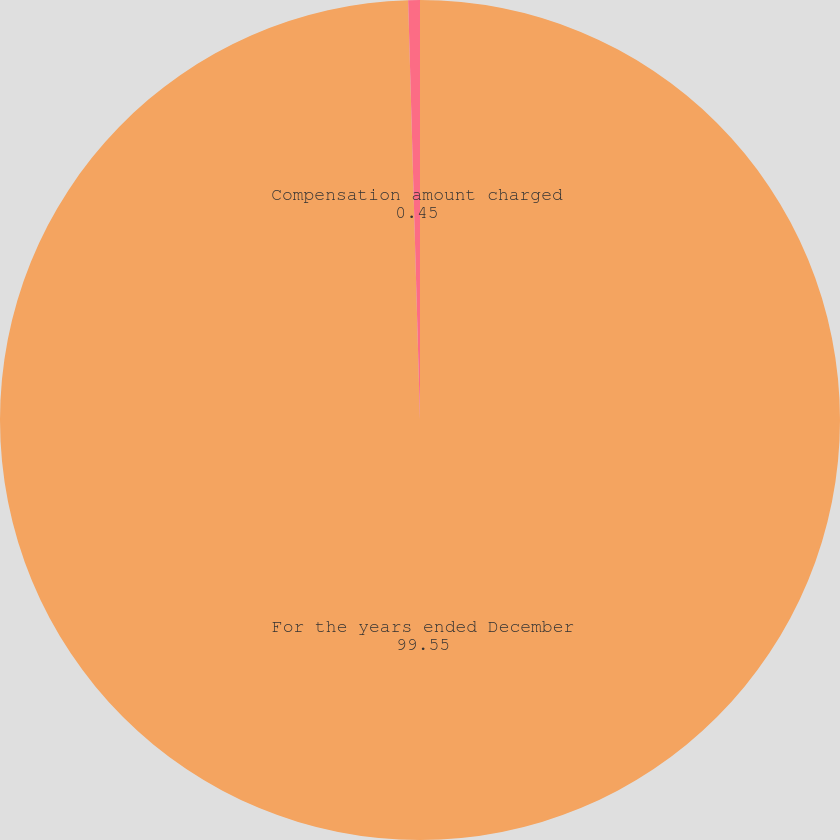Convert chart to OTSL. <chart><loc_0><loc_0><loc_500><loc_500><pie_chart><fcel>For the years ended December<fcel>Compensation amount charged<nl><fcel>99.55%<fcel>0.45%<nl></chart> 